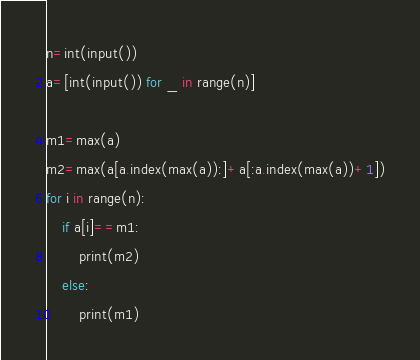Convert code to text. <code><loc_0><loc_0><loc_500><loc_500><_Python_>n=int(input())
a=[int(input()) for _ in range(n)]

m1=max(a)
m2=max(a[a.index(max(a)):]+a[:a.index(max(a))+1])
for i in range(n):
    if a[i]==m1:
        print(m2)
    else:
        print(m1)
</code> 